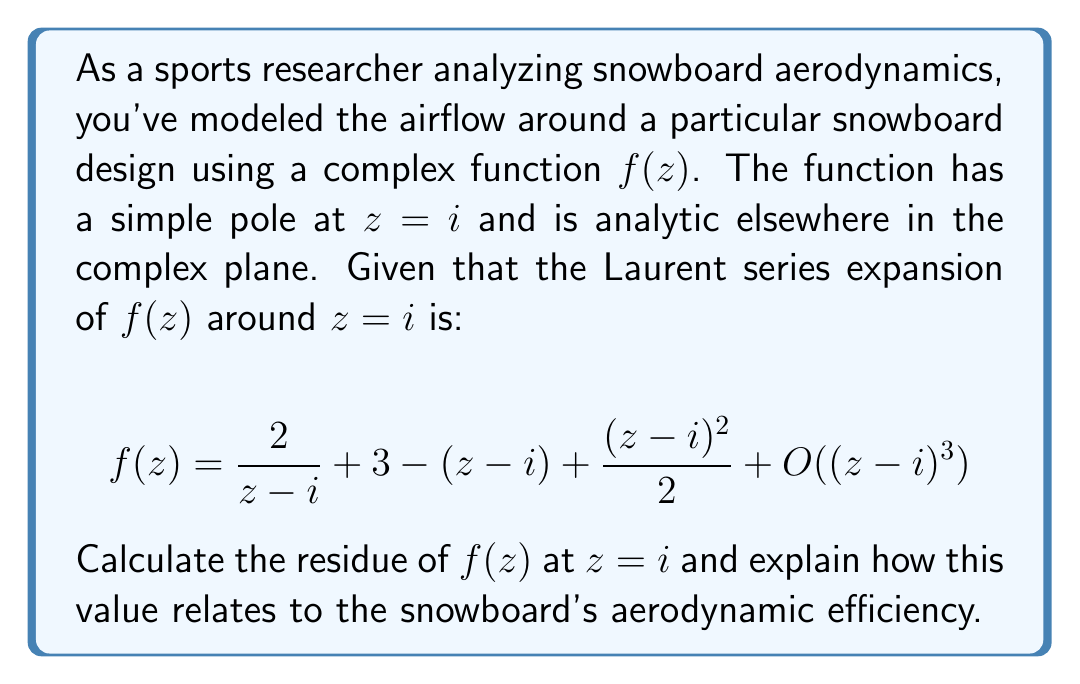Provide a solution to this math problem. To solve this problem, we'll follow these steps:

1) Recall that for a Laurent series expansion around a point $a$:

   $$f(z) = \sum_{n=-\infty}^{\infty} a_n(z-a)^n$$

   The residue at $z=a$ is given by the coefficient $a_{-1}$.

2) In our case, the Laurent series is expanded around $z=i$, and we have:

   $$f(z) = \frac{2}{z-i} + 3 - (z-i) + \frac{(z-i)^2}{2} + O((z-i)^3)$$

3) Comparing this to the general form, we can identify:

   $a_{-1} = 2$
   $a_0 = 3$
   $a_1 = -1$
   $a_2 = \frac{1}{2}$

4) Therefore, the residue of $f(z)$ at $z=i$ is 2.

5) In the context of snowboard aerodynamics, the residue can be interpreted as a measure of the "circulation" of air around the snowboard at the point $z=i$. A higher absolute value of the residue indicates a stronger vortex or circulation point, which can affect the snowboard's aerodynamic efficiency.

6) The positive value of the residue (2) suggests a counterclockwise circulation. This could indicate an area where air is being "pushed" away from the snowboard, potentially reducing drag.

7) The magnitude of the residue (2) is relatively small, which might suggest that this particular point doesn't have a dramatic effect on the overall aerodynamics. However, to fully assess the snowboard's aerodynamic efficiency, we would need to consider the behavior of $f(z)$ at other points and analyze the complete flow pattern around the snowboard.
Answer: The residue of $f(z)$ at $z=i$ is 2. This positive value indicates a counterclockwise circulation at this point, which could contribute to reduced drag and improved aerodynamic efficiency of the snowboard design. 